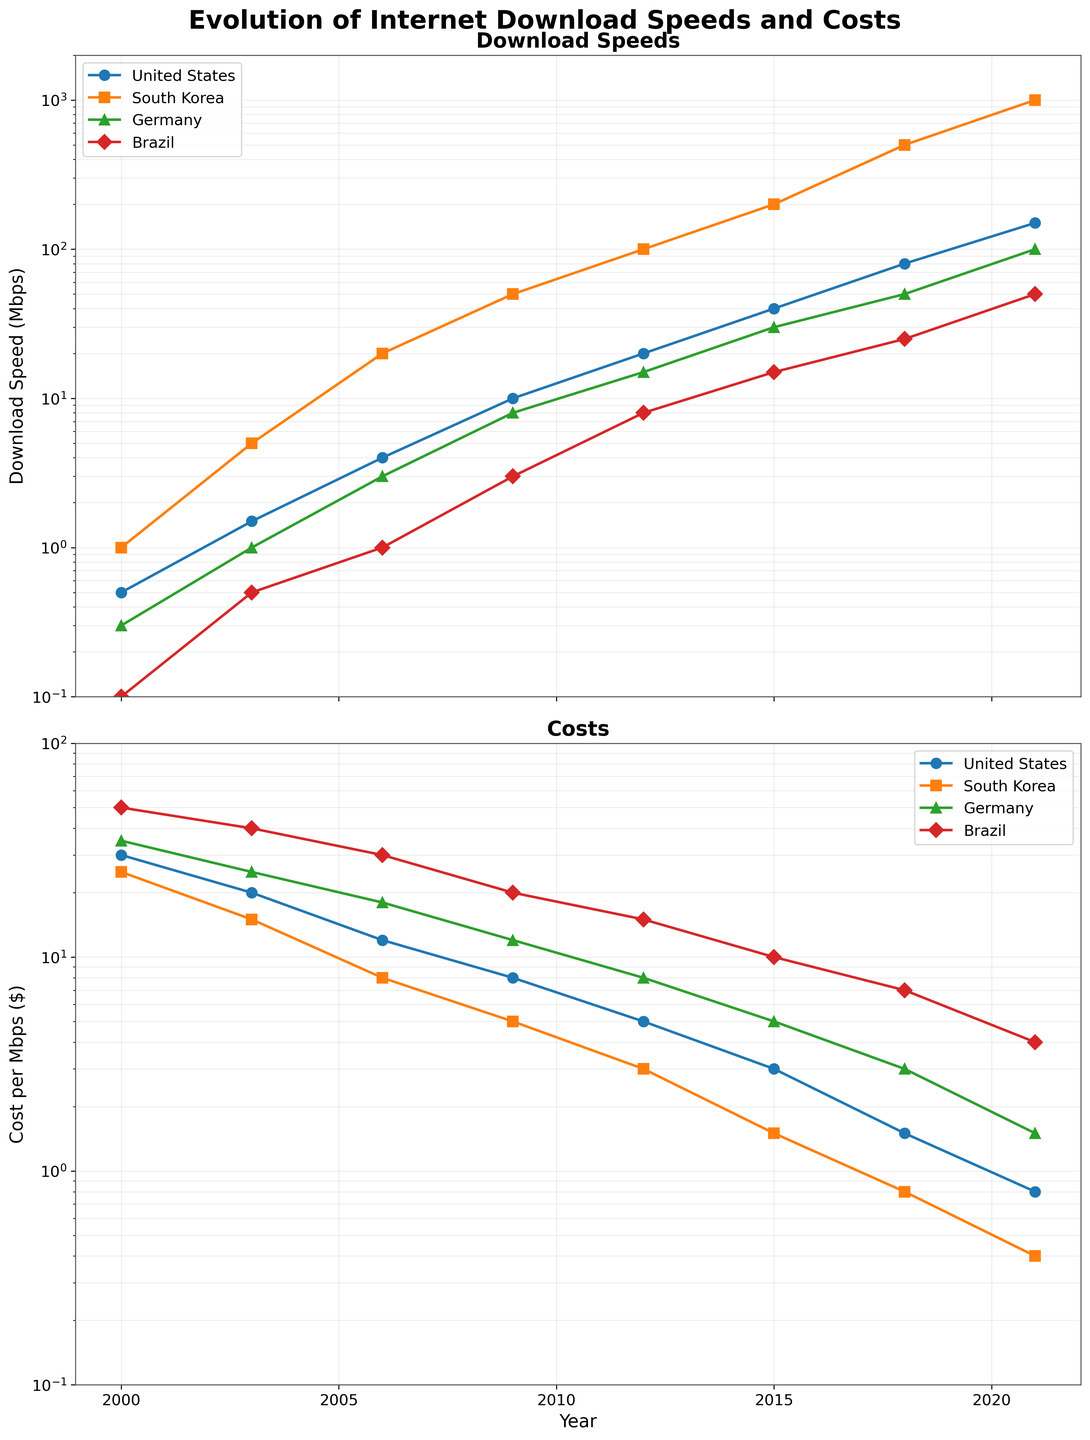Which country had the highest download speed in 2021? Look at the end of the download speed line chart for 2021 for all countries. The highest point corresponds to South Korea.
Answer: South Korea Which country had the lowest cost per Mbps in 2000? Check the beginning of the cost per Mbps line chart for the year 2000 for all countries. The lowest point corresponds to South Korea.
Answer: South Korea What is the average download speed for Germany over the entire period shown? Sum up all the download speeds for Germany: 0.3 + 1.0 + 3.0 + 8.0 + 15.0 + 30.0 + 50.0 + 100.0 = 207.3. The total number of data points is 8. Calculate the average by dividing the sum by the number of data points: 207.3 / 8.
Answer: 25.91 How much did the cost per Mbps change for Brazil from 2000 to 2021? Note the cost per Mbps for Brazil in 2000 (50.00) and in 2021 (4.00). Calculate the difference: 50.00 - 4.00 = 46.00.
Answer: 46.00 Which country showed the greatest improvement in download speeds between 2000 and 2021? Calculate the increase in download speeds for each country from 2000 to 2021: 
- United States: 150.0 - 0.5 = 149.5 
- South Korea: 1000.0 - 1.0 = 999.0
- Germany: 100.0 - 0.3 = 99.7 
- Brazil: 50.0 - 0.1 = 49.9. 
The greatest improvement corresponds to South Korea.
Answer: South Korea What year did the United States first exceed a 10 Mbps download speed? Follow the line representing United States download speeds and find the year it first passes the 10 Mbps mark. This occurs in 2009.
Answer: 2009 How do the trends in cost per Mbps compare between South Korea and Germany from 2000 to 2021? Observe the overall direction (decrease or increase) and slope of the lines representing cost per Mbps for South Korea and Germany. South Korea's costs consistently decrease at a steep slope, while Germany’s costs also decrease but at a less steep slope. Both countries show a decreasing trend, but South Korea's has a more dramatic drop.
Answer: Both decrease, South Korea more drastically Which country had the highest cost per Mbps in 2006, and how much was it? Identify the peaks in the cost per Mbps chart for 2006 for all countries. The highest point is Germany at $18.00 per Mbps.
Answer: Germany, 18.00 Between 2009 and 2018, which country saw the largest drop in cost per Mbps and by how much? Calculate the decrease in cost per Mbps for each country from 2009 to 2018:
- United States: 8.00 - 1.50 = 6.50
- South Korea: 5.00 - 0.80 = 4.20
- Germany: 12.00 - 3.00 = 9.00
- Brazil: 20.00 - 7.00 = 13.00 
The largest drop is for Brazil with a decrease of 13.00.
Answer: Brazil, 13.00 